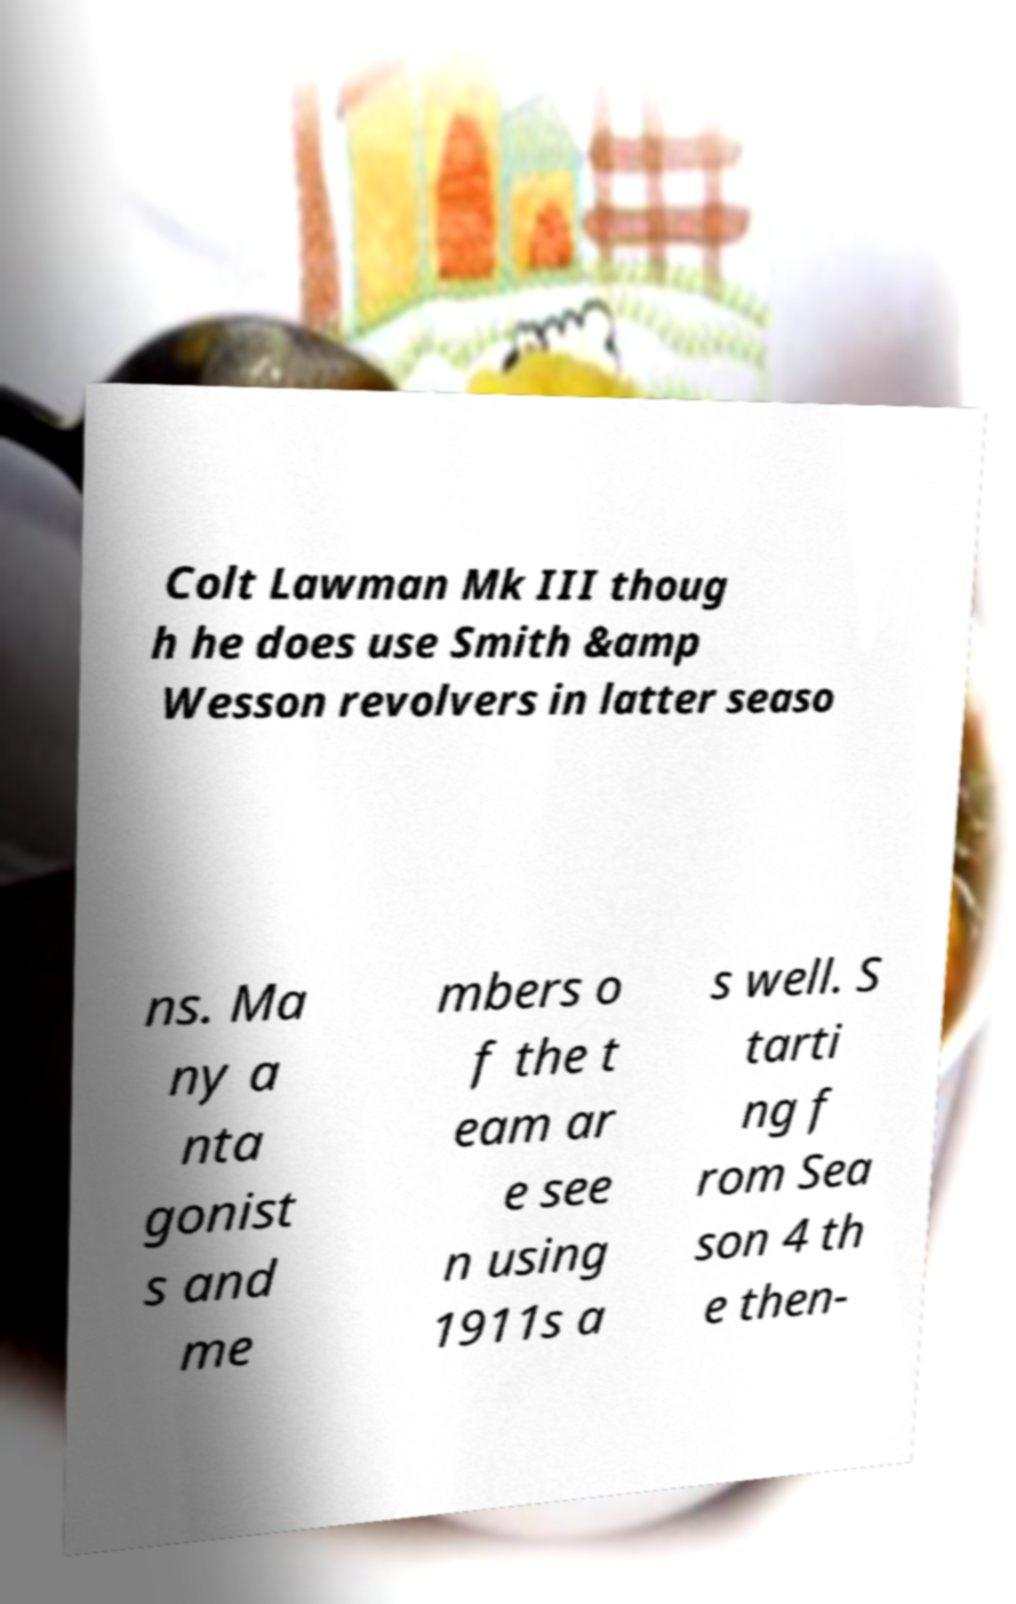Please read and relay the text visible in this image. What does it say? Colt Lawman Mk III thoug h he does use Smith &amp Wesson revolvers in latter seaso ns. Ma ny a nta gonist s and me mbers o f the t eam ar e see n using 1911s a s well. S tarti ng f rom Sea son 4 th e then- 